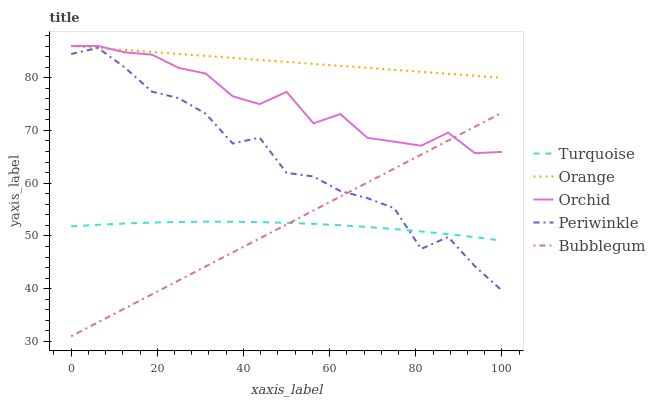Does Turquoise have the minimum area under the curve?
Answer yes or no. Yes. Does Orange have the maximum area under the curve?
Answer yes or no. Yes. Does Periwinkle have the minimum area under the curve?
Answer yes or no. No. Does Periwinkle have the maximum area under the curve?
Answer yes or no. No. Is Bubblegum the smoothest?
Answer yes or no. Yes. Is Periwinkle the roughest?
Answer yes or no. Yes. Is Turquoise the smoothest?
Answer yes or no. No. Is Turquoise the roughest?
Answer yes or no. No. Does Turquoise have the lowest value?
Answer yes or no. No. Does Periwinkle have the highest value?
Answer yes or no. No. Is Turquoise less than Orchid?
Answer yes or no. Yes. Is Orange greater than Bubblegum?
Answer yes or no. Yes. Does Turquoise intersect Orchid?
Answer yes or no. No. 